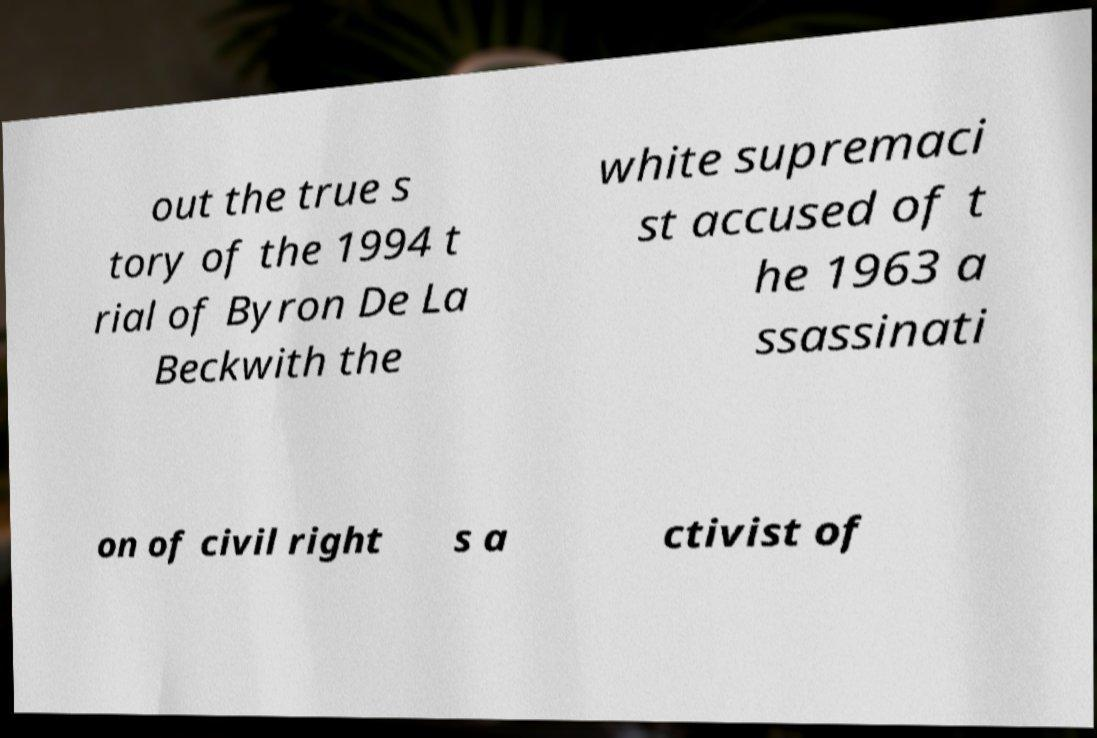There's text embedded in this image that I need extracted. Can you transcribe it verbatim? out the true s tory of the 1994 t rial of Byron De La Beckwith the white supremaci st accused of t he 1963 a ssassinati on of civil right s a ctivist of 